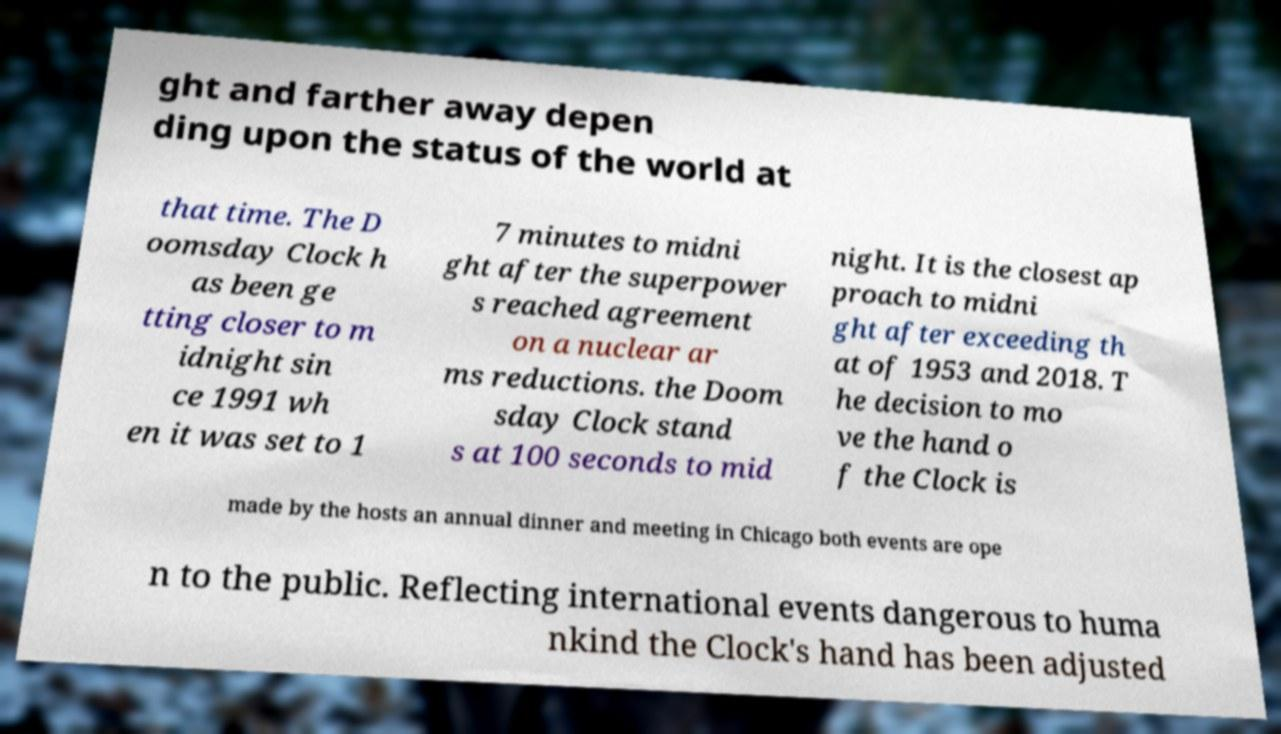Please read and relay the text visible in this image. What does it say? ght and farther away depen ding upon the status of the world at that time. The D oomsday Clock h as been ge tting closer to m idnight sin ce 1991 wh en it was set to 1 7 minutes to midni ght after the superpower s reached agreement on a nuclear ar ms reductions. the Doom sday Clock stand s at 100 seconds to mid night. It is the closest ap proach to midni ght after exceeding th at of 1953 and 2018. T he decision to mo ve the hand o f the Clock is made by the hosts an annual dinner and meeting in Chicago both events are ope n to the public. Reflecting international events dangerous to huma nkind the Clock's hand has been adjusted 